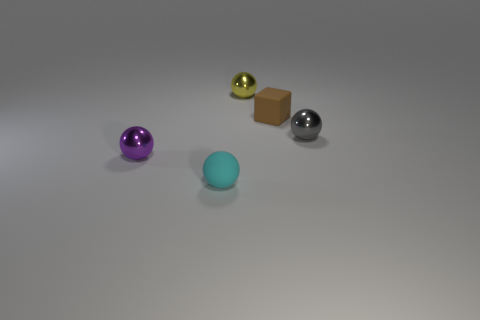Subtract all matte balls. How many balls are left? 3 Subtract 3 balls. How many balls are left? 1 Add 1 tiny green matte cubes. How many objects exist? 6 Subtract all purple balls. How many balls are left? 3 Subtract 0 yellow blocks. How many objects are left? 5 Subtract all blocks. How many objects are left? 4 Subtract all green cubes. Subtract all yellow cylinders. How many cubes are left? 1 Subtract all large blue rubber objects. Subtract all gray metallic things. How many objects are left? 4 Add 4 tiny purple things. How many tiny purple things are left? 5 Add 3 cyan matte objects. How many cyan matte objects exist? 4 